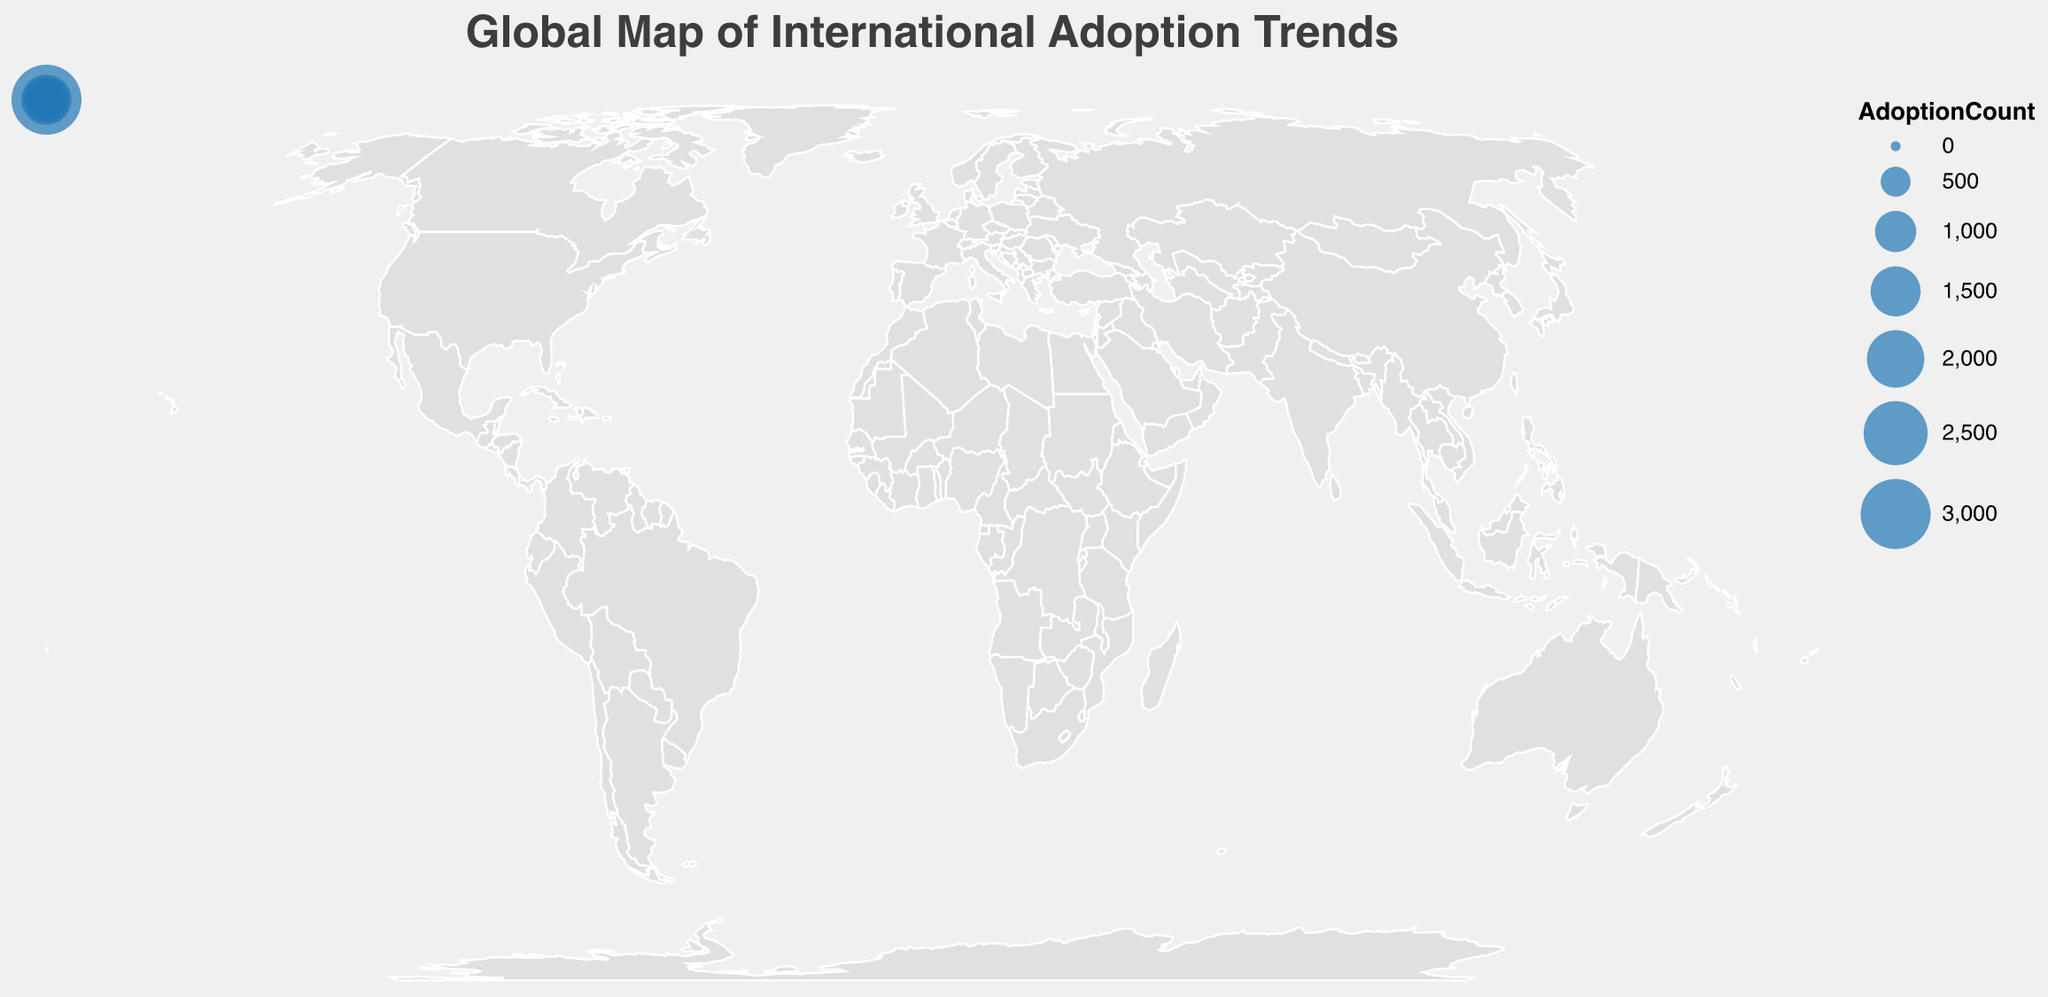What is the origin country with the highest number of adoptions to the United States? According to the figure, the United States receives the highest number of adoptions from China, with an AdoptionCount of 3000.
Answer: China How many adoption paths have more than 700 adoptions? In the figure, adoptions from China to the U.S. (3000), Russia to Spain (1500), Ethiopia to France (1200), and South Korea to Canada (800) all exceed 700 adoptions.
Answer: 4 Which continent has the most origin countries? By visually assessing the figure, Asia leads with China, South Korea, India, Vietnam, and Kazakhstan as origin countries.
Answer: Asia What is the total number of adoptions from European countries? Adding the figures: Russia to Spain (1500), Ukraine to Italy (700), Bulgaria to Belgium (150), and Poland to Switzerland (100), we get a total of 2450.
Answer: 2450 What are the destination countries for adoptions from Africa? The adoption paths from Ethiopia to France and Haiti to Germany are the ones originating from African countries. France and Germany are the destination countries.
Answer: France, Germany Which destination country receives the least adoptions? Ireland receives the fewest adoptions from Kazakhstan, with 80 adoptions.
Answer: Ireland Compare the adoption counts from China to the United States and India to the Netherlands. Which is higher, and by how much? The figure shows 3000 adoptions from China to the U.S. and 500 from India to the Netherlands. 3000 - 500 = 2500, so U.S. adoption count is higher by 2500.
Answer: 2500 Identify a pair of regions each serving as both an origin and a destination. Russia and Spain form such a pair. Russia is the origin for Spain, and in general, the European region can act in both roles.
Answer: Russia and Spain What is the average number of adoptions from origin countries to European destination countries? Summing the adoptions to Spain (1500), France (1200), Italy (700), Sweden (600), Germany (400), United Kingdom (300), Denmark (250), Norway (200), Belgium (150), Switzerland (100), Ireland (80) totals to 5480, divided by 11 destination countries, the average is 498.18.
Answer: 498.18 Which regions form the highest and the lowest volume adoption paths, and what are their values? The highest volume adoption path is from China to the United States (3000) and the lowest from Kazakhstan to Ireland (80).
Answer: China to United States: 3000, Kazakhstan to Ireland: 80 